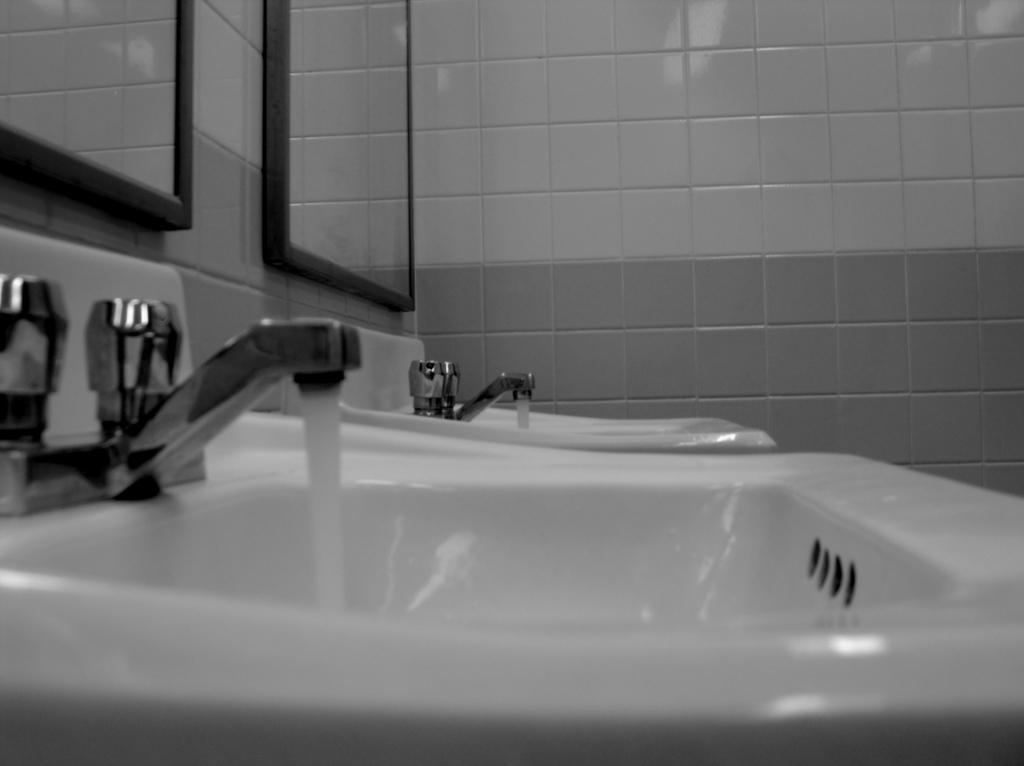How would you summarize this image in a sentence or two? In the image we can see there are two hand wash sinks and the taps are kept opened, water is flowing. There are mirrors on the wall and there are tiles on the wall. 